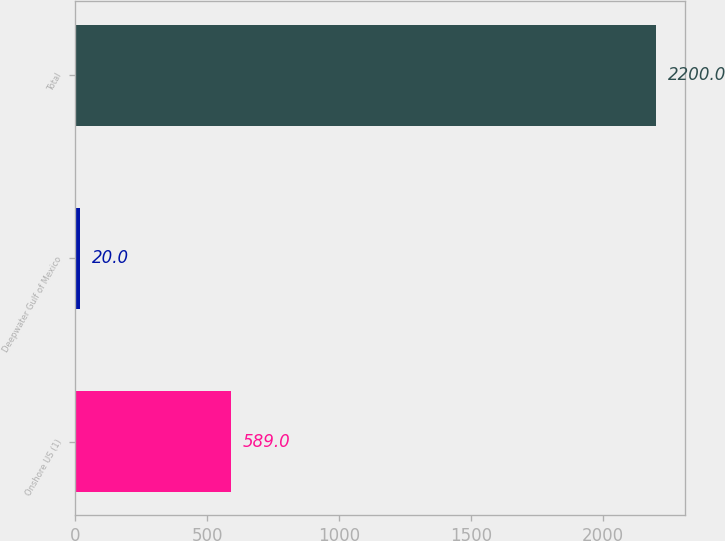Convert chart to OTSL. <chart><loc_0><loc_0><loc_500><loc_500><bar_chart><fcel>Onshore US (1)<fcel>Deepwater Gulf of Mexico<fcel>Total<nl><fcel>589<fcel>20<fcel>2200<nl></chart> 